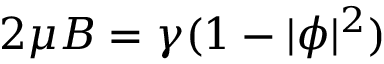<formula> <loc_0><loc_0><loc_500><loc_500>2 \mu B = \gamma ( 1 - | \phi | ^ { 2 } )</formula> 